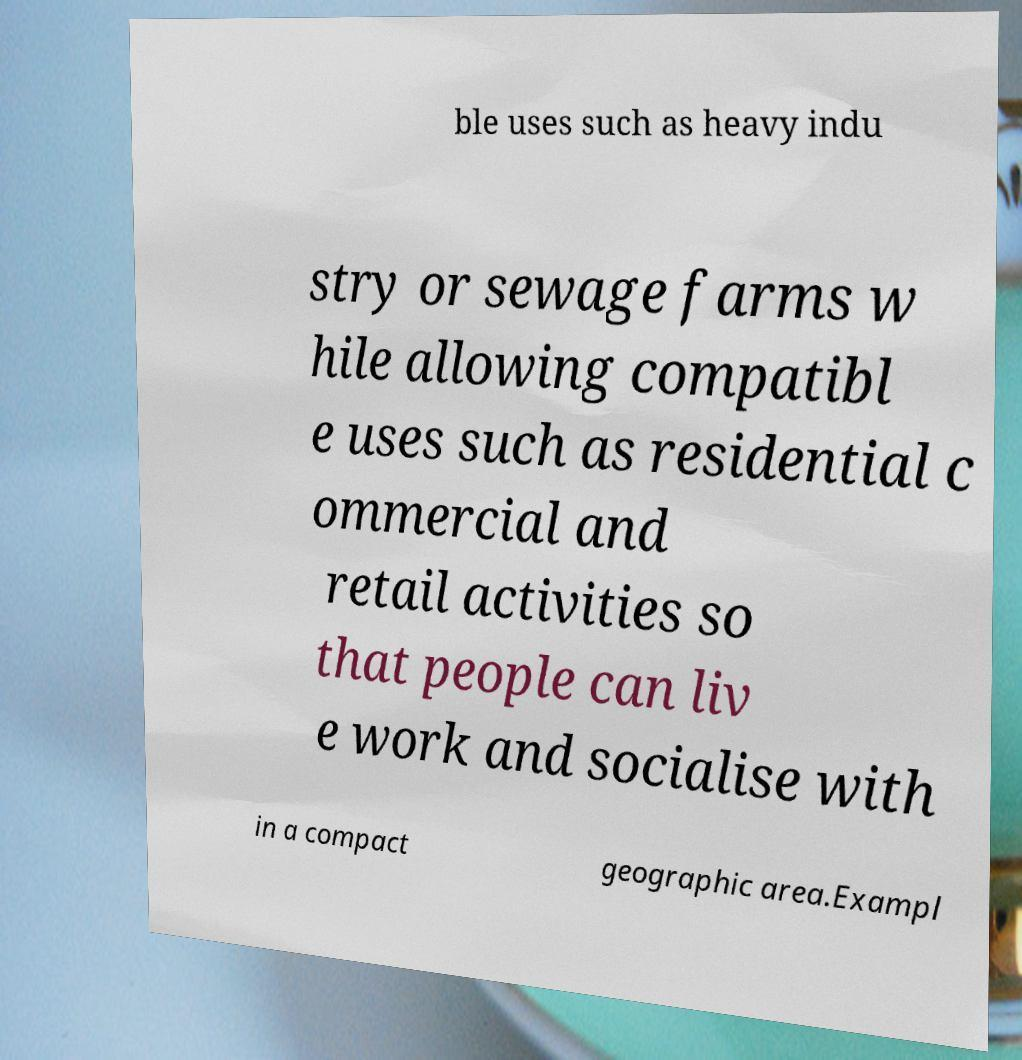Could you extract and type out the text from this image? ble uses such as heavy indu stry or sewage farms w hile allowing compatibl e uses such as residential c ommercial and retail activities so that people can liv e work and socialise with in a compact geographic area.Exampl 